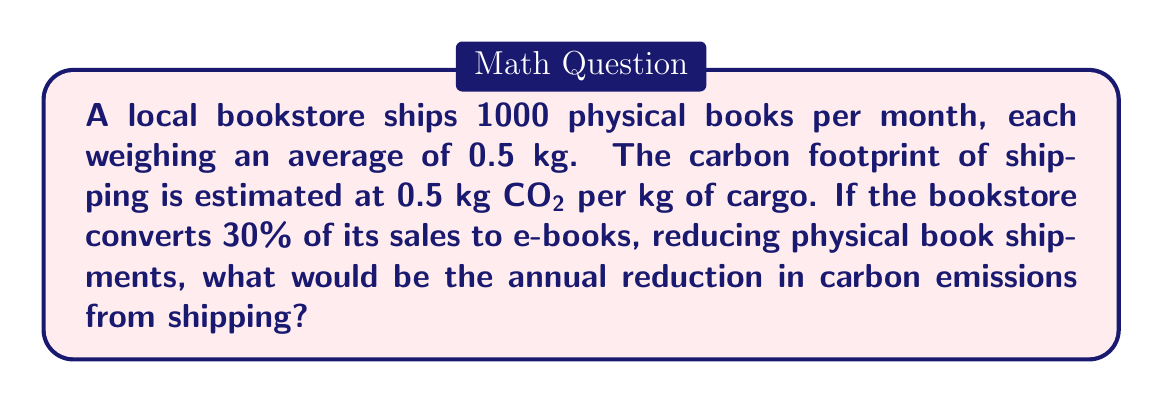Can you answer this question? Let's approach this step-by-step:

1. Calculate the total weight of books shipped monthly:
   $1000 \text{ books} \times 0.5 \text{ kg/book} = 500 \text{ kg}$

2. Calculate the monthly carbon footprint from shipping:
   $500 \text{ kg} \times 0.5 \text{ kg CO}_2\text{/kg} = 250 \text{ kg CO}_2$

3. Calculate the reduction in physical book shipments:
   $30\% \text{ of } 1000 \text{ books} = 0.3 \times 1000 = 300 \text{ books}$

4. Calculate the new monthly shipment after reduction:
   $1000 - 300 = 700 \text{ books}$

5. Calculate the new monthly carbon footprint:
   $700 \text{ books} \times 0.5 \text{ kg/book} \times 0.5 \text{ kg CO}_2\text{/kg} = 175 \text{ kg CO}_2$

6. Calculate the monthly reduction in carbon footprint:
   $250 \text{ kg CO}_2 - 175 \text{ kg CO}_2 = 75 \text{ kg CO}_2$

7. Calculate the annual reduction:
   $75 \text{ kg CO}_2\text{/month} \times 12 \text{ months} = 900 \text{ kg CO}_2$

Therefore, the annual reduction in carbon emissions from shipping would be 900 kg CO₂.
Answer: 900 kg CO₂ 